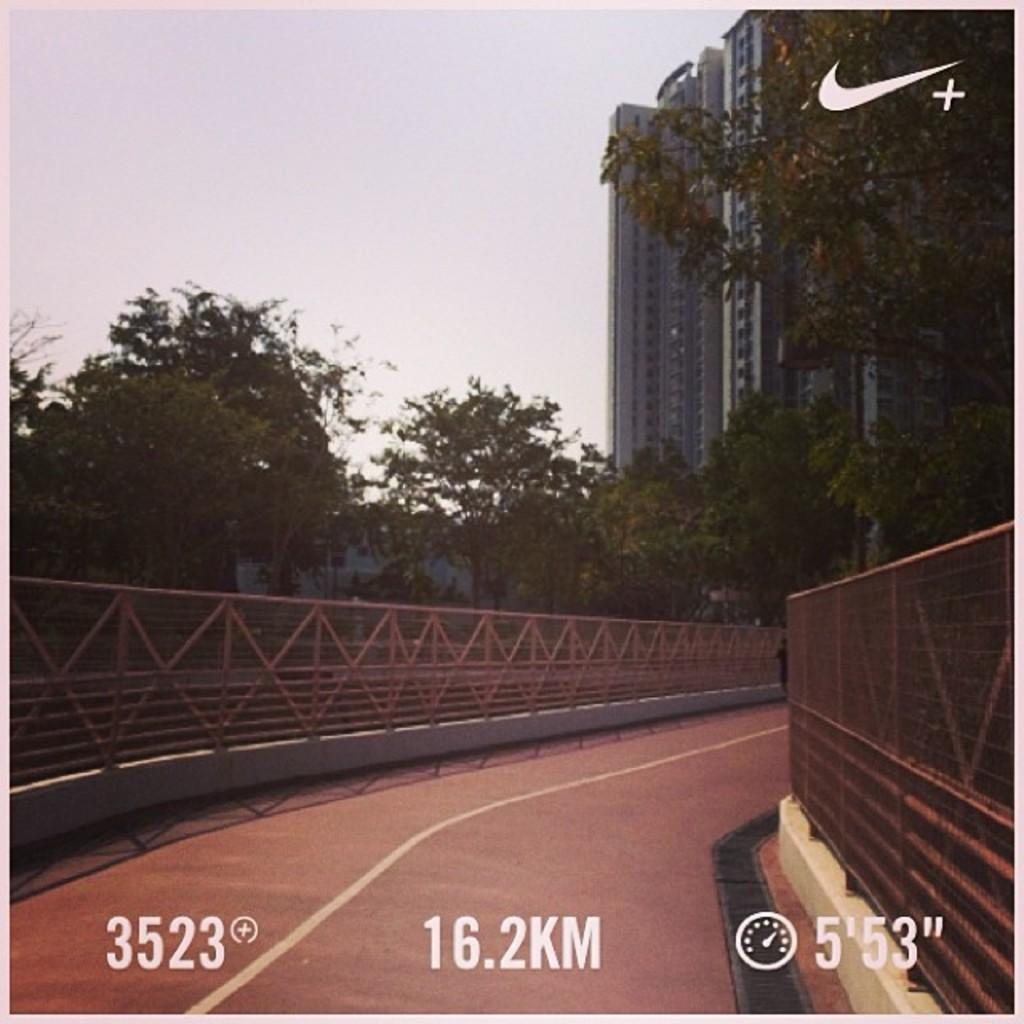What is the main feature of the image? There is a road in the image. Is there any text or marking on the image? Yes, a watermark is present at the bottom of the image. What can be seen in the background of the image? There is a fence, trees, and a building visible in the background of the image. What is visible at the top of the image? The sky is visible at the top of the image. How many skates are being used on the railway in the image? There is no railway or skates present in the image. What is the mass of the object in the image? The image does not depict a single object that can be measured for mass. 